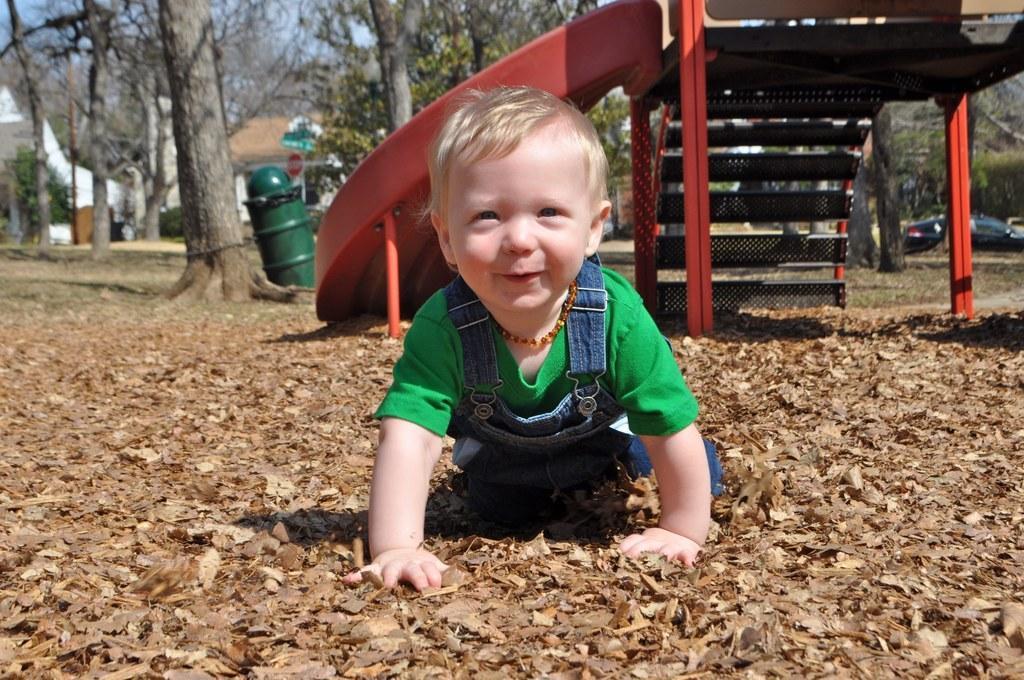Describe this image in one or two sentences. In the picture we can see a baby boy crawling on the dried leaf surface and behind him we can see a playground object and beside it, we can see a tree and a dustbin and in the background surroundings, we can see a car, some trees and some houses and behind it we can see a part of the sky from the trees. 